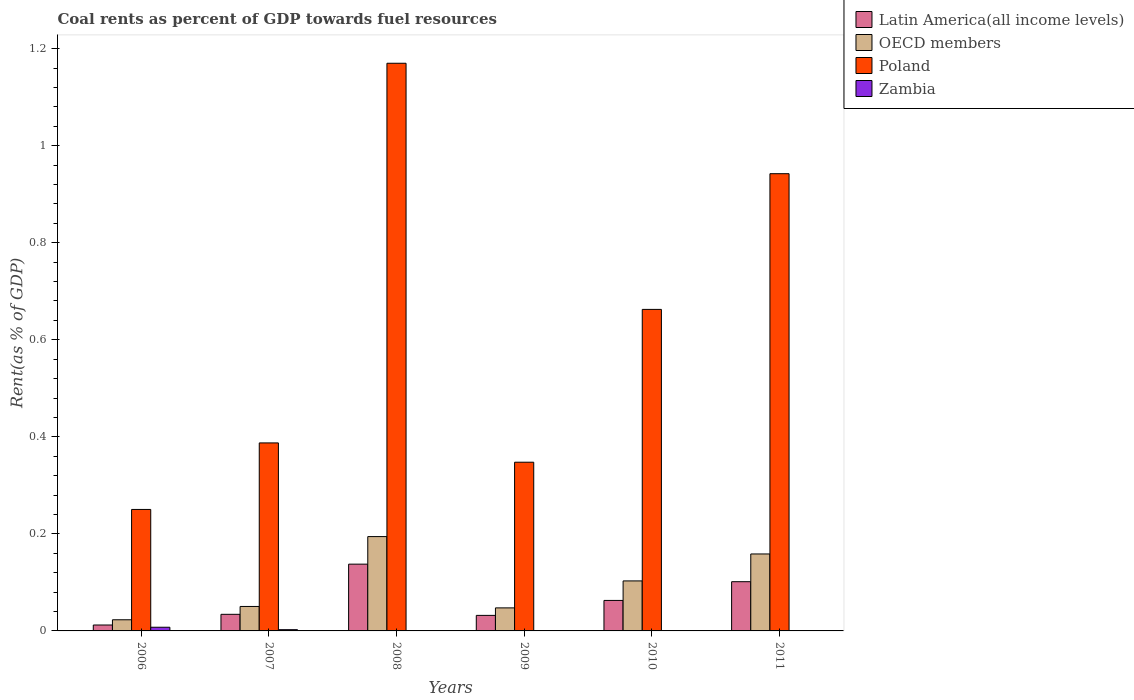How many groups of bars are there?
Ensure brevity in your answer.  6. Are the number of bars on each tick of the X-axis equal?
Provide a short and direct response. Yes. In how many cases, is the number of bars for a given year not equal to the number of legend labels?
Ensure brevity in your answer.  0. What is the coal rent in Zambia in 2011?
Your answer should be very brief. 0. Across all years, what is the maximum coal rent in Poland?
Your response must be concise. 1.17. Across all years, what is the minimum coal rent in Zambia?
Your response must be concise. 0. What is the total coal rent in Zambia in the graph?
Your response must be concise. 0.01. What is the difference between the coal rent in OECD members in 2010 and that in 2011?
Keep it short and to the point. -0.06. What is the difference between the coal rent in Zambia in 2011 and the coal rent in Poland in 2007?
Make the answer very short. -0.39. What is the average coal rent in Latin America(all income levels) per year?
Offer a terse response. 0.06. In the year 2011, what is the difference between the coal rent in Latin America(all income levels) and coal rent in Poland?
Give a very brief answer. -0.84. What is the ratio of the coal rent in Poland in 2009 to that in 2011?
Your response must be concise. 0.37. Is the coal rent in Latin America(all income levels) in 2007 less than that in 2011?
Offer a very short reply. Yes. What is the difference between the highest and the second highest coal rent in Latin America(all income levels)?
Ensure brevity in your answer.  0.04. What is the difference between the highest and the lowest coal rent in OECD members?
Make the answer very short. 0.17. Is the sum of the coal rent in Poland in 2007 and 2011 greater than the maximum coal rent in OECD members across all years?
Your answer should be very brief. Yes. What does the 4th bar from the left in 2010 represents?
Your response must be concise. Zambia. How many bars are there?
Offer a terse response. 24. Are all the bars in the graph horizontal?
Provide a succinct answer. No. How many years are there in the graph?
Offer a very short reply. 6. What is the difference between two consecutive major ticks on the Y-axis?
Your answer should be very brief. 0.2. Are the values on the major ticks of Y-axis written in scientific E-notation?
Your answer should be compact. No. How are the legend labels stacked?
Give a very brief answer. Vertical. What is the title of the graph?
Your response must be concise. Coal rents as percent of GDP towards fuel resources. Does "Micronesia" appear as one of the legend labels in the graph?
Make the answer very short. No. What is the label or title of the Y-axis?
Offer a very short reply. Rent(as % of GDP). What is the Rent(as % of GDP) in Latin America(all income levels) in 2006?
Your answer should be compact. 0.01. What is the Rent(as % of GDP) of OECD members in 2006?
Your answer should be very brief. 0.02. What is the Rent(as % of GDP) in Poland in 2006?
Keep it short and to the point. 0.25. What is the Rent(as % of GDP) of Zambia in 2006?
Your response must be concise. 0.01. What is the Rent(as % of GDP) of Latin America(all income levels) in 2007?
Offer a very short reply. 0.03. What is the Rent(as % of GDP) in OECD members in 2007?
Your answer should be very brief. 0.05. What is the Rent(as % of GDP) of Poland in 2007?
Provide a succinct answer. 0.39. What is the Rent(as % of GDP) of Zambia in 2007?
Provide a succinct answer. 0. What is the Rent(as % of GDP) in Latin America(all income levels) in 2008?
Your answer should be very brief. 0.14. What is the Rent(as % of GDP) of OECD members in 2008?
Offer a terse response. 0.19. What is the Rent(as % of GDP) of Poland in 2008?
Your response must be concise. 1.17. What is the Rent(as % of GDP) of Zambia in 2008?
Ensure brevity in your answer.  0. What is the Rent(as % of GDP) of Latin America(all income levels) in 2009?
Your answer should be compact. 0.03. What is the Rent(as % of GDP) of OECD members in 2009?
Your answer should be compact. 0.05. What is the Rent(as % of GDP) of Poland in 2009?
Offer a very short reply. 0.35. What is the Rent(as % of GDP) of Zambia in 2009?
Make the answer very short. 0. What is the Rent(as % of GDP) of Latin America(all income levels) in 2010?
Provide a succinct answer. 0.06. What is the Rent(as % of GDP) in OECD members in 2010?
Ensure brevity in your answer.  0.1. What is the Rent(as % of GDP) in Poland in 2010?
Offer a terse response. 0.66. What is the Rent(as % of GDP) of Zambia in 2010?
Provide a short and direct response. 0. What is the Rent(as % of GDP) in Latin America(all income levels) in 2011?
Your answer should be very brief. 0.1. What is the Rent(as % of GDP) of OECD members in 2011?
Your response must be concise. 0.16. What is the Rent(as % of GDP) of Poland in 2011?
Provide a succinct answer. 0.94. What is the Rent(as % of GDP) in Zambia in 2011?
Give a very brief answer. 0. Across all years, what is the maximum Rent(as % of GDP) of Latin America(all income levels)?
Your answer should be compact. 0.14. Across all years, what is the maximum Rent(as % of GDP) of OECD members?
Offer a terse response. 0.19. Across all years, what is the maximum Rent(as % of GDP) of Poland?
Your answer should be very brief. 1.17. Across all years, what is the maximum Rent(as % of GDP) of Zambia?
Make the answer very short. 0.01. Across all years, what is the minimum Rent(as % of GDP) of Latin America(all income levels)?
Offer a terse response. 0.01. Across all years, what is the minimum Rent(as % of GDP) in OECD members?
Provide a short and direct response. 0.02. Across all years, what is the minimum Rent(as % of GDP) of Poland?
Keep it short and to the point. 0.25. Across all years, what is the minimum Rent(as % of GDP) of Zambia?
Give a very brief answer. 0. What is the total Rent(as % of GDP) in Latin America(all income levels) in the graph?
Offer a terse response. 0.38. What is the total Rent(as % of GDP) in OECD members in the graph?
Your answer should be compact. 0.58. What is the total Rent(as % of GDP) in Poland in the graph?
Provide a short and direct response. 3.76. What is the total Rent(as % of GDP) of Zambia in the graph?
Your response must be concise. 0.01. What is the difference between the Rent(as % of GDP) in Latin America(all income levels) in 2006 and that in 2007?
Keep it short and to the point. -0.02. What is the difference between the Rent(as % of GDP) of OECD members in 2006 and that in 2007?
Provide a short and direct response. -0.03. What is the difference between the Rent(as % of GDP) of Poland in 2006 and that in 2007?
Provide a succinct answer. -0.14. What is the difference between the Rent(as % of GDP) of Zambia in 2006 and that in 2007?
Provide a succinct answer. 0.01. What is the difference between the Rent(as % of GDP) of Latin America(all income levels) in 2006 and that in 2008?
Give a very brief answer. -0.13. What is the difference between the Rent(as % of GDP) in OECD members in 2006 and that in 2008?
Ensure brevity in your answer.  -0.17. What is the difference between the Rent(as % of GDP) of Poland in 2006 and that in 2008?
Keep it short and to the point. -0.92. What is the difference between the Rent(as % of GDP) in Zambia in 2006 and that in 2008?
Provide a short and direct response. 0.01. What is the difference between the Rent(as % of GDP) in Latin America(all income levels) in 2006 and that in 2009?
Keep it short and to the point. -0.02. What is the difference between the Rent(as % of GDP) in OECD members in 2006 and that in 2009?
Your answer should be very brief. -0.02. What is the difference between the Rent(as % of GDP) of Poland in 2006 and that in 2009?
Your answer should be very brief. -0.1. What is the difference between the Rent(as % of GDP) in Zambia in 2006 and that in 2009?
Make the answer very short. 0.01. What is the difference between the Rent(as % of GDP) in Latin America(all income levels) in 2006 and that in 2010?
Provide a short and direct response. -0.05. What is the difference between the Rent(as % of GDP) in OECD members in 2006 and that in 2010?
Keep it short and to the point. -0.08. What is the difference between the Rent(as % of GDP) in Poland in 2006 and that in 2010?
Provide a short and direct response. -0.41. What is the difference between the Rent(as % of GDP) in Zambia in 2006 and that in 2010?
Provide a short and direct response. 0.01. What is the difference between the Rent(as % of GDP) in Latin America(all income levels) in 2006 and that in 2011?
Provide a succinct answer. -0.09. What is the difference between the Rent(as % of GDP) of OECD members in 2006 and that in 2011?
Give a very brief answer. -0.14. What is the difference between the Rent(as % of GDP) in Poland in 2006 and that in 2011?
Ensure brevity in your answer.  -0.69. What is the difference between the Rent(as % of GDP) in Zambia in 2006 and that in 2011?
Offer a very short reply. 0.01. What is the difference between the Rent(as % of GDP) in Latin America(all income levels) in 2007 and that in 2008?
Provide a short and direct response. -0.1. What is the difference between the Rent(as % of GDP) in OECD members in 2007 and that in 2008?
Your answer should be very brief. -0.14. What is the difference between the Rent(as % of GDP) of Poland in 2007 and that in 2008?
Your response must be concise. -0.78. What is the difference between the Rent(as % of GDP) of Zambia in 2007 and that in 2008?
Provide a short and direct response. 0. What is the difference between the Rent(as % of GDP) in Latin America(all income levels) in 2007 and that in 2009?
Your answer should be very brief. 0. What is the difference between the Rent(as % of GDP) in OECD members in 2007 and that in 2009?
Make the answer very short. 0. What is the difference between the Rent(as % of GDP) in Poland in 2007 and that in 2009?
Your response must be concise. 0.04. What is the difference between the Rent(as % of GDP) in Zambia in 2007 and that in 2009?
Your answer should be compact. 0. What is the difference between the Rent(as % of GDP) in Latin America(all income levels) in 2007 and that in 2010?
Keep it short and to the point. -0.03. What is the difference between the Rent(as % of GDP) of OECD members in 2007 and that in 2010?
Your answer should be compact. -0.05. What is the difference between the Rent(as % of GDP) in Poland in 2007 and that in 2010?
Keep it short and to the point. -0.28. What is the difference between the Rent(as % of GDP) in Zambia in 2007 and that in 2010?
Make the answer very short. 0. What is the difference between the Rent(as % of GDP) of Latin America(all income levels) in 2007 and that in 2011?
Offer a very short reply. -0.07. What is the difference between the Rent(as % of GDP) in OECD members in 2007 and that in 2011?
Give a very brief answer. -0.11. What is the difference between the Rent(as % of GDP) in Poland in 2007 and that in 2011?
Your response must be concise. -0.55. What is the difference between the Rent(as % of GDP) in Zambia in 2007 and that in 2011?
Give a very brief answer. 0. What is the difference between the Rent(as % of GDP) of Latin America(all income levels) in 2008 and that in 2009?
Ensure brevity in your answer.  0.11. What is the difference between the Rent(as % of GDP) of OECD members in 2008 and that in 2009?
Make the answer very short. 0.15. What is the difference between the Rent(as % of GDP) in Poland in 2008 and that in 2009?
Ensure brevity in your answer.  0.82. What is the difference between the Rent(as % of GDP) of Zambia in 2008 and that in 2009?
Keep it short and to the point. 0. What is the difference between the Rent(as % of GDP) in Latin America(all income levels) in 2008 and that in 2010?
Offer a terse response. 0.07. What is the difference between the Rent(as % of GDP) of OECD members in 2008 and that in 2010?
Your answer should be compact. 0.09. What is the difference between the Rent(as % of GDP) in Poland in 2008 and that in 2010?
Offer a terse response. 0.51. What is the difference between the Rent(as % of GDP) of Latin America(all income levels) in 2008 and that in 2011?
Ensure brevity in your answer.  0.04. What is the difference between the Rent(as % of GDP) of OECD members in 2008 and that in 2011?
Your answer should be compact. 0.04. What is the difference between the Rent(as % of GDP) of Poland in 2008 and that in 2011?
Provide a short and direct response. 0.23. What is the difference between the Rent(as % of GDP) in Zambia in 2008 and that in 2011?
Ensure brevity in your answer.  0. What is the difference between the Rent(as % of GDP) of Latin America(all income levels) in 2009 and that in 2010?
Your answer should be very brief. -0.03. What is the difference between the Rent(as % of GDP) in OECD members in 2009 and that in 2010?
Offer a terse response. -0.06. What is the difference between the Rent(as % of GDP) of Poland in 2009 and that in 2010?
Your answer should be compact. -0.32. What is the difference between the Rent(as % of GDP) in Zambia in 2009 and that in 2010?
Your answer should be compact. -0. What is the difference between the Rent(as % of GDP) of Latin America(all income levels) in 2009 and that in 2011?
Give a very brief answer. -0.07. What is the difference between the Rent(as % of GDP) of OECD members in 2009 and that in 2011?
Make the answer very short. -0.11. What is the difference between the Rent(as % of GDP) of Poland in 2009 and that in 2011?
Give a very brief answer. -0.59. What is the difference between the Rent(as % of GDP) in Zambia in 2009 and that in 2011?
Your answer should be compact. -0. What is the difference between the Rent(as % of GDP) of Latin America(all income levels) in 2010 and that in 2011?
Your answer should be very brief. -0.04. What is the difference between the Rent(as % of GDP) of OECD members in 2010 and that in 2011?
Your answer should be compact. -0.06. What is the difference between the Rent(as % of GDP) in Poland in 2010 and that in 2011?
Ensure brevity in your answer.  -0.28. What is the difference between the Rent(as % of GDP) in Zambia in 2010 and that in 2011?
Give a very brief answer. -0. What is the difference between the Rent(as % of GDP) in Latin America(all income levels) in 2006 and the Rent(as % of GDP) in OECD members in 2007?
Keep it short and to the point. -0.04. What is the difference between the Rent(as % of GDP) in Latin America(all income levels) in 2006 and the Rent(as % of GDP) in Poland in 2007?
Offer a terse response. -0.38. What is the difference between the Rent(as % of GDP) in Latin America(all income levels) in 2006 and the Rent(as % of GDP) in Zambia in 2007?
Keep it short and to the point. 0.01. What is the difference between the Rent(as % of GDP) of OECD members in 2006 and the Rent(as % of GDP) of Poland in 2007?
Offer a terse response. -0.36. What is the difference between the Rent(as % of GDP) in OECD members in 2006 and the Rent(as % of GDP) in Zambia in 2007?
Give a very brief answer. 0.02. What is the difference between the Rent(as % of GDP) in Poland in 2006 and the Rent(as % of GDP) in Zambia in 2007?
Make the answer very short. 0.25. What is the difference between the Rent(as % of GDP) of Latin America(all income levels) in 2006 and the Rent(as % of GDP) of OECD members in 2008?
Keep it short and to the point. -0.18. What is the difference between the Rent(as % of GDP) of Latin America(all income levels) in 2006 and the Rent(as % of GDP) of Poland in 2008?
Ensure brevity in your answer.  -1.16. What is the difference between the Rent(as % of GDP) of Latin America(all income levels) in 2006 and the Rent(as % of GDP) of Zambia in 2008?
Your answer should be compact. 0.01. What is the difference between the Rent(as % of GDP) in OECD members in 2006 and the Rent(as % of GDP) in Poland in 2008?
Offer a terse response. -1.15. What is the difference between the Rent(as % of GDP) in OECD members in 2006 and the Rent(as % of GDP) in Zambia in 2008?
Your answer should be very brief. 0.02. What is the difference between the Rent(as % of GDP) in Poland in 2006 and the Rent(as % of GDP) in Zambia in 2008?
Keep it short and to the point. 0.25. What is the difference between the Rent(as % of GDP) of Latin America(all income levels) in 2006 and the Rent(as % of GDP) of OECD members in 2009?
Offer a very short reply. -0.04. What is the difference between the Rent(as % of GDP) in Latin America(all income levels) in 2006 and the Rent(as % of GDP) in Poland in 2009?
Ensure brevity in your answer.  -0.34. What is the difference between the Rent(as % of GDP) of Latin America(all income levels) in 2006 and the Rent(as % of GDP) of Zambia in 2009?
Keep it short and to the point. 0.01. What is the difference between the Rent(as % of GDP) of OECD members in 2006 and the Rent(as % of GDP) of Poland in 2009?
Ensure brevity in your answer.  -0.32. What is the difference between the Rent(as % of GDP) in OECD members in 2006 and the Rent(as % of GDP) in Zambia in 2009?
Offer a terse response. 0.02. What is the difference between the Rent(as % of GDP) of Poland in 2006 and the Rent(as % of GDP) of Zambia in 2009?
Offer a very short reply. 0.25. What is the difference between the Rent(as % of GDP) of Latin America(all income levels) in 2006 and the Rent(as % of GDP) of OECD members in 2010?
Keep it short and to the point. -0.09. What is the difference between the Rent(as % of GDP) of Latin America(all income levels) in 2006 and the Rent(as % of GDP) of Poland in 2010?
Make the answer very short. -0.65. What is the difference between the Rent(as % of GDP) in Latin America(all income levels) in 2006 and the Rent(as % of GDP) in Zambia in 2010?
Your answer should be compact. 0.01. What is the difference between the Rent(as % of GDP) in OECD members in 2006 and the Rent(as % of GDP) in Poland in 2010?
Make the answer very short. -0.64. What is the difference between the Rent(as % of GDP) of OECD members in 2006 and the Rent(as % of GDP) of Zambia in 2010?
Your answer should be compact. 0.02. What is the difference between the Rent(as % of GDP) in Poland in 2006 and the Rent(as % of GDP) in Zambia in 2010?
Provide a succinct answer. 0.25. What is the difference between the Rent(as % of GDP) in Latin America(all income levels) in 2006 and the Rent(as % of GDP) in OECD members in 2011?
Keep it short and to the point. -0.15. What is the difference between the Rent(as % of GDP) of Latin America(all income levels) in 2006 and the Rent(as % of GDP) of Poland in 2011?
Provide a succinct answer. -0.93. What is the difference between the Rent(as % of GDP) of Latin America(all income levels) in 2006 and the Rent(as % of GDP) of Zambia in 2011?
Offer a terse response. 0.01. What is the difference between the Rent(as % of GDP) in OECD members in 2006 and the Rent(as % of GDP) in Poland in 2011?
Provide a succinct answer. -0.92. What is the difference between the Rent(as % of GDP) of OECD members in 2006 and the Rent(as % of GDP) of Zambia in 2011?
Give a very brief answer. 0.02. What is the difference between the Rent(as % of GDP) of Poland in 2006 and the Rent(as % of GDP) of Zambia in 2011?
Your response must be concise. 0.25. What is the difference between the Rent(as % of GDP) of Latin America(all income levels) in 2007 and the Rent(as % of GDP) of OECD members in 2008?
Keep it short and to the point. -0.16. What is the difference between the Rent(as % of GDP) in Latin America(all income levels) in 2007 and the Rent(as % of GDP) in Poland in 2008?
Your answer should be very brief. -1.14. What is the difference between the Rent(as % of GDP) in Latin America(all income levels) in 2007 and the Rent(as % of GDP) in Zambia in 2008?
Provide a short and direct response. 0.03. What is the difference between the Rent(as % of GDP) of OECD members in 2007 and the Rent(as % of GDP) of Poland in 2008?
Your answer should be very brief. -1.12. What is the difference between the Rent(as % of GDP) of OECD members in 2007 and the Rent(as % of GDP) of Zambia in 2008?
Offer a very short reply. 0.05. What is the difference between the Rent(as % of GDP) in Poland in 2007 and the Rent(as % of GDP) in Zambia in 2008?
Make the answer very short. 0.39. What is the difference between the Rent(as % of GDP) of Latin America(all income levels) in 2007 and the Rent(as % of GDP) of OECD members in 2009?
Give a very brief answer. -0.01. What is the difference between the Rent(as % of GDP) of Latin America(all income levels) in 2007 and the Rent(as % of GDP) of Poland in 2009?
Your response must be concise. -0.31. What is the difference between the Rent(as % of GDP) of Latin America(all income levels) in 2007 and the Rent(as % of GDP) of Zambia in 2009?
Provide a short and direct response. 0.03. What is the difference between the Rent(as % of GDP) in OECD members in 2007 and the Rent(as % of GDP) in Poland in 2009?
Keep it short and to the point. -0.3. What is the difference between the Rent(as % of GDP) of OECD members in 2007 and the Rent(as % of GDP) of Zambia in 2009?
Your answer should be very brief. 0.05. What is the difference between the Rent(as % of GDP) of Poland in 2007 and the Rent(as % of GDP) of Zambia in 2009?
Make the answer very short. 0.39. What is the difference between the Rent(as % of GDP) in Latin America(all income levels) in 2007 and the Rent(as % of GDP) in OECD members in 2010?
Your answer should be very brief. -0.07. What is the difference between the Rent(as % of GDP) of Latin America(all income levels) in 2007 and the Rent(as % of GDP) of Poland in 2010?
Your answer should be compact. -0.63. What is the difference between the Rent(as % of GDP) in Latin America(all income levels) in 2007 and the Rent(as % of GDP) in Zambia in 2010?
Provide a short and direct response. 0.03. What is the difference between the Rent(as % of GDP) in OECD members in 2007 and the Rent(as % of GDP) in Poland in 2010?
Make the answer very short. -0.61. What is the difference between the Rent(as % of GDP) of OECD members in 2007 and the Rent(as % of GDP) of Zambia in 2010?
Make the answer very short. 0.05. What is the difference between the Rent(as % of GDP) in Poland in 2007 and the Rent(as % of GDP) in Zambia in 2010?
Provide a short and direct response. 0.39. What is the difference between the Rent(as % of GDP) of Latin America(all income levels) in 2007 and the Rent(as % of GDP) of OECD members in 2011?
Your answer should be compact. -0.12. What is the difference between the Rent(as % of GDP) of Latin America(all income levels) in 2007 and the Rent(as % of GDP) of Poland in 2011?
Give a very brief answer. -0.91. What is the difference between the Rent(as % of GDP) in Latin America(all income levels) in 2007 and the Rent(as % of GDP) in Zambia in 2011?
Offer a very short reply. 0.03. What is the difference between the Rent(as % of GDP) of OECD members in 2007 and the Rent(as % of GDP) of Poland in 2011?
Your response must be concise. -0.89. What is the difference between the Rent(as % of GDP) in OECD members in 2007 and the Rent(as % of GDP) in Zambia in 2011?
Make the answer very short. 0.05. What is the difference between the Rent(as % of GDP) of Poland in 2007 and the Rent(as % of GDP) of Zambia in 2011?
Offer a very short reply. 0.39. What is the difference between the Rent(as % of GDP) in Latin America(all income levels) in 2008 and the Rent(as % of GDP) in OECD members in 2009?
Your answer should be compact. 0.09. What is the difference between the Rent(as % of GDP) in Latin America(all income levels) in 2008 and the Rent(as % of GDP) in Poland in 2009?
Your answer should be compact. -0.21. What is the difference between the Rent(as % of GDP) of Latin America(all income levels) in 2008 and the Rent(as % of GDP) of Zambia in 2009?
Give a very brief answer. 0.14. What is the difference between the Rent(as % of GDP) in OECD members in 2008 and the Rent(as % of GDP) in Poland in 2009?
Offer a very short reply. -0.15. What is the difference between the Rent(as % of GDP) in OECD members in 2008 and the Rent(as % of GDP) in Zambia in 2009?
Give a very brief answer. 0.19. What is the difference between the Rent(as % of GDP) of Poland in 2008 and the Rent(as % of GDP) of Zambia in 2009?
Make the answer very short. 1.17. What is the difference between the Rent(as % of GDP) of Latin America(all income levels) in 2008 and the Rent(as % of GDP) of OECD members in 2010?
Your response must be concise. 0.03. What is the difference between the Rent(as % of GDP) of Latin America(all income levels) in 2008 and the Rent(as % of GDP) of Poland in 2010?
Provide a succinct answer. -0.53. What is the difference between the Rent(as % of GDP) in Latin America(all income levels) in 2008 and the Rent(as % of GDP) in Zambia in 2010?
Provide a short and direct response. 0.14. What is the difference between the Rent(as % of GDP) of OECD members in 2008 and the Rent(as % of GDP) of Poland in 2010?
Offer a very short reply. -0.47. What is the difference between the Rent(as % of GDP) in OECD members in 2008 and the Rent(as % of GDP) in Zambia in 2010?
Your answer should be very brief. 0.19. What is the difference between the Rent(as % of GDP) of Poland in 2008 and the Rent(as % of GDP) of Zambia in 2010?
Provide a succinct answer. 1.17. What is the difference between the Rent(as % of GDP) of Latin America(all income levels) in 2008 and the Rent(as % of GDP) of OECD members in 2011?
Provide a short and direct response. -0.02. What is the difference between the Rent(as % of GDP) of Latin America(all income levels) in 2008 and the Rent(as % of GDP) of Poland in 2011?
Your answer should be very brief. -0.8. What is the difference between the Rent(as % of GDP) of Latin America(all income levels) in 2008 and the Rent(as % of GDP) of Zambia in 2011?
Your response must be concise. 0.14. What is the difference between the Rent(as % of GDP) of OECD members in 2008 and the Rent(as % of GDP) of Poland in 2011?
Keep it short and to the point. -0.75. What is the difference between the Rent(as % of GDP) of OECD members in 2008 and the Rent(as % of GDP) of Zambia in 2011?
Provide a succinct answer. 0.19. What is the difference between the Rent(as % of GDP) in Poland in 2008 and the Rent(as % of GDP) in Zambia in 2011?
Keep it short and to the point. 1.17. What is the difference between the Rent(as % of GDP) of Latin America(all income levels) in 2009 and the Rent(as % of GDP) of OECD members in 2010?
Provide a short and direct response. -0.07. What is the difference between the Rent(as % of GDP) in Latin America(all income levels) in 2009 and the Rent(as % of GDP) in Poland in 2010?
Offer a terse response. -0.63. What is the difference between the Rent(as % of GDP) in Latin America(all income levels) in 2009 and the Rent(as % of GDP) in Zambia in 2010?
Provide a short and direct response. 0.03. What is the difference between the Rent(as % of GDP) of OECD members in 2009 and the Rent(as % of GDP) of Poland in 2010?
Provide a succinct answer. -0.62. What is the difference between the Rent(as % of GDP) in OECD members in 2009 and the Rent(as % of GDP) in Zambia in 2010?
Your answer should be very brief. 0.05. What is the difference between the Rent(as % of GDP) in Poland in 2009 and the Rent(as % of GDP) in Zambia in 2010?
Ensure brevity in your answer.  0.35. What is the difference between the Rent(as % of GDP) of Latin America(all income levels) in 2009 and the Rent(as % of GDP) of OECD members in 2011?
Provide a succinct answer. -0.13. What is the difference between the Rent(as % of GDP) in Latin America(all income levels) in 2009 and the Rent(as % of GDP) in Poland in 2011?
Ensure brevity in your answer.  -0.91. What is the difference between the Rent(as % of GDP) of Latin America(all income levels) in 2009 and the Rent(as % of GDP) of Zambia in 2011?
Offer a very short reply. 0.03. What is the difference between the Rent(as % of GDP) of OECD members in 2009 and the Rent(as % of GDP) of Poland in 2011?
Provide a succinct answer. -0.89. What is the difference between the Rent(as % of GDP) of OECD members in 2009 and the Rent(as % of GDP) of Zambia in 2011?
Provide a short and direct response. 0.05. What is the difference between the Rent(as % of GDP) of Poland in 2009 and the Rent(as % of GDP) of Zambia in 2011?
Your response must be concise. 0.35. What is the difference between the Rent(as % of GDP) in Latin America(all income levels) in 2010 and the Rent(as % of GDP) in OECD members in 2011?
Offer a terse response. -0.1. What is the difference between the Rent(as % of GDP) of Latin America(all income levels) in 2010 and the Rent(as % of GDP) of Poland in 2011?
Your answer should be very brief. -0.88. What is the difference between the Rent(as % of GDP) of Latin America(all income levels) in 2010 and the Rent(as % of GDP) of Zambia in 2011?
Your answer should be compact. 0.06. What is the difference between the Rent(as % of GDP) in OECD members in 2010 and the Rent(as % of GDP) in Poland in 2011?
Your response must be concise. -0.84. What is the difference between the Rent(as % of GDP) of OECD members in 2010 and the Rent(as % of GDP) of Zambia in 2011?
Provide a short and direct response. 0.1. What is the difference between the Rent(as % of GDP) in Poland in 2010 and the Rent(as % of GDP) in Zambia in 2011?
Ensure brevity in your answer.  0.66. What is the average Rent(as % of GDP) in Latin America(all income levels) per year?
Provide a succinct answer. 0.06. What is the average Rent(as % of GDP) in OECD members per year?
Make the answer very short. 0.1. What is the average Rent(as % of GDP) of Poland per year?
Provide a short and direct response. 0.63. What is the average Rent(as % of GDP) of Zambia per year?
Make the answer very short. 0. In the year 2006, what is the difference between the Rent(as % of GDP) of Latin America(all income levels) and Rent(as % of GDP) of OECD members?
Your response must be concise. -0.01. In the year 2006, what is the difference between the Rent(as % of GDP) of Latin America(all income levels) and Rent(as % of GDP) of Poland?
Provide a succinct answer. -0.24. In the year 2006, what is the difference between the Rent(as % of GDP) of Latin America(all income levels) and Rent(as % of GDP) of Zambia?
Your answer should be compact. 0. In the year 2006, what is the difference between the Rent(as % of GDP) in OECD members and Rent(as % of GDP) in Poland?
Give a very brief answer. -0.23. In the year 2006, what is the difference between the Rent(as % of GDP) of OECD members and Rent(as % of GDP) of Zambia?
Ensure brevity in your answer.  0.02. In the year 2006, what is the difference between the Rent(as % of GDP) of Poland and Rent(as % of GDP) of Zambia?
Give a very brief answer. 0.24. In the year 2007, what is the difference between the Rent(as % of GDP) of Latin America(all income levels) and Rent(as % of GDP) of OECD members?
Offer a terse response. -0.02. In the year 2007, what is the difference between the Rent(as % of GDP) in Latin America(all income levels) and Rent(as % of GDP) in Poland?
Ensure brevity in your answer.  -0.35. In the year 2007, what is the difference between the Rent(as % of GDP) in Latin America(all income levels) and Rent(as % of GDP) in Zambia?
Make the answer very short. 0.03. In the year 2007, what is the difference between the Rent(as % of GDP) of OECD members and Rent(as % of GDP) of Poland?
Your response must be concise. -0.34. In the year 2007, what is the difference between the Rent(as % of GDP) of OECD members and Rent(as % of GDP) of Zambia?
Make the answer very short. 0.05. In the year 2007, what is the difference between the Rent(as % of GDP) of Poland and Rent(as % of GDP) of Zambia?
Offer a terse response. 0.38. In the year 2008, what is the difference between the Rent(as % of GDP) in Latin America(all income levels) and Rent(as % of GDP) in OECD members?
Offer a terse response. -0.06. In the year 2008, what is the difference between the Rent(as % of GDP) in Latin America(all income levels) and Rent(as % of GDP) in Poland?
Offer a very short reply. -1.03. In the year 2008, what is the difference between the Rent(as % of GDP) of Latin America(all income levels) and Rent(as % of GDP) of Zambia?
Provide a short and direct response. 0.14. In the year 2008, what is the difference between the Rent(as % of GDP) of OECD members and Rent(as % of GDP) of Poland?
Keep it short and to the point. -0.98. In the year 2008, what is the difference between the Rent(as % of GDP) in OECD members and Rent(as % of GDP) in Zambia?
Offer a terse response. 0.19. In the year 2008, what is the difference between the Rent(as % of GDP) in Poland and Rent(as % of GDP) in Zambia?
Provide a succinct answer. 1.17. In the year 2009, what is the difference between the Rent(as % of GDP) of Latin America(all income levels) and Rent(as % of GDP) of OECD members?
Provide a succinct answer. -0.02. In the year 2009, what is the difference between the Rent(as % of GDP) in Latin America(all income levels) and Rent(as % of GDP) in Poland?
Ensure brevity in your answer.  -0.32. In the year 2009, what is the difference between the Rent(as % of GDP) in Latin America(all income levels) and Rent(as % of GDP) in Zambia?
Ensure brevity in your answer.  0.03. In the year 2009, what is the difference between the Rent(as % of GDP) in OECD members and Rent(as % of GDP) in Poland?
Give a very brief answer. -0.3. In the year 2009, what is the difference between the Rent(as % of GDP) of OECD members and Rent(as % of GDP) of Zambia?
Your answer should be compact. 0.05. In the year 2009, what is the difference between the Rent(as % of GDP) of Poland and Rent(as % of GDP) of Zambia?
Give a very brief answer. 0.35. In the year 2010, what is the difference between the Rent(as % of GDP) of Latin America(all income levels) and Rent(as % of GDP) of OECD members?
Give a very brief answer. -0.04. In the year 2010, what is the difference between the Rent(as % of GDP) of Latin America(all income levels) and Rent(as % of GDP) of Poland?
Offer a very short reply. -0.6. In the year 2010, what is the difference between the Rent(as % of GDP) of Latin America(all income levels) and Rent(as % of GDP) of Zambia?
Your answer should be compact. 0.06. In the year 2010, what is the difference between the Rent(as % of GDP) of OECD members and Rent(as % of GDP) of Poland?
Ensure brevity in your answer.  -0.56. In the year 2010, what is the difference between the Rent(as % of GDP) in OECD members and Rent(as % of GDP) in Zambia?
Give a very brief answer. 0.1. In the year 2010, what is the difference between the Rent(as % of GDP) in Poland and Rent(as % of GDP) in Zambia?
Ensure brevity in your answer.  0.66. In the year 2011, what is the difference between the Rent(as % of GDP) of Latin America(all income levels) and Rent(as % of GDP) of OECD members?
Your response must be concise. -0.06. In the year 2011, what is the difference between the Rent(as % of GDP) in Latin America(all income levels) and Rent(as % of GDP) in Poland?
Provide a succinct answer. -0.84. In the year 2011, what is the difference between the Rent(as % of GDP) in Latin America(all income levels) and Rent(as % of GDP) in Zambia?
Your answer should be very brief. 0.1. In the year 2011, what is the difference between the Rent(as % of GDP) in OECD members and Rent(as % of GDP) in Poland?
Give a very brief answer. -0.78. In the year 2011, what is the difference between the Rent(as % of GDP) of OECD members and Rent(as % of GDP) of Zambia?
Provide a short and direct response. 0.16. In the year 2011, what is the difference between the Rent(as % of GDP) in Poland and Rent(as % of GDP) in Zambia?
Offer a very short reply. 0.94. What is the ratio of the Rent(as % of GDP) of Latin America(all income levels) in 2006 to that in 2007?
Provide a succinct answer. 0.36. What is the ratio of the Rent(as % of GDP) in OECD members in 2006 to that in 2007?
Offer a terse response. 0.46. What is the ratio of the Rent(as % of GDP) of Poland in 2006 to that in 2007?
Ensure brevity in your answer.  0.65. What is the ratio of the Rent(as % of GDP) in Zambia in 2006 to that in 2007?
Keep it short and to the point. 2.96. What is the ratio of the Rent(as % of GDP) of Latin America(all income levels) in 2006 to that in 2008?
Give a very brief answer. 0.09. What is the ratio of the Rent(as % of GDP) in OECD members in 2006 to that in 2008?
Your response must be concise. 0.12. What is the ratio of the Rent(as % of GDP) in Poland in 2006 to that in 2008?
Provide a succinct answer. 0.21. What is the ratio of the Rent(as % of GDP) in Zambia in 2006 to that in 2008?
Offer a very short reply. 17.16. What is the ratio of the Rent(as % of GDP) in Latin America(all income levels) in 2006 to that in 2009?
Make the answer very short. 0.38. What is the ratio of the Rent(as % of GDP) in OECD members in 2006 to that in 2009?
Offer a very short reply. 0.48. What is the ratio of the Rent(as % of GDP) in Poland in 2006 to that in 2009?
Offer a very short reply. 0.72. What is the ratio of the Rent(as % of GDP) of Zambia in 2006 to that in 2009?
Ensure brevity in your answer.  43.63. What is the ratio of the Rent(as % of GDP) of Latin America(all income levels) in 2006 to that in 2010?
Your answer should be compact. 0.19. What is the ratio of the Rent(as % of GDP) of OECD members in 2006 to that in 2010?
Provide a succinct answer. 0.22. What is the ratio of the Rent(as % of GDP) of Poland in 2006 to that in 2010?
Your answer should be very brief. 0.38. What is the ratio of the Rent(as % of GDP) in Zambia in 2006 to that in 2010?
Ensure brevity in your answer.  31.8. What is the ratio of the Rent(as % of GDP) of Latin America(all income levels) in 2006 to that in 2011?
Your answer should be very brief. 0.12. What is the ratio of the Rent(as % of GDP) of OECD members in 2006 to that in 2011?
Offer a very short reply. 0.14. What is the ratio of the Rent(as % of GDP) of Poland in 2006 to that in 2011?
Ensure brevity in your answer.  0.27. What is the ratio of the Rent(as % of GDP) in Zambia in 2006 to that in 2011?
Your answer should be very brief. 25.55. What is the ratio of the Rent(as % of GDP) in Latin America(all income levels) in 2007 to that in 2008?
Ensure brevity in your answer.  0.25. What is the ratio of the Rent(as % of GDP) in OECD members in 2007 to that in 2008?
Keep it short and to the point. 0.26. What is the ratio of the Rent(as % of GDP) of Poland in 2007 to that in 2008?
Make the answer very short. 0.33. What is the ratio of the Rent(as % of GDP) in Zambia in 2007 to that in 2008?
Provide a short and direct response. 5.81. What is the ratio of the Rent(as % of GDP) in Latin America(all income levels) in 2007 to that in 2009?
Your answer should be compact. 1.07. What is the ratio of the Rent(as % of GDP) of OECD members in 2007 to that in 2009?
Provide a short and direct response. 1.06. What is the ratio of the Rent(as % of GDP) in Poland in 2007 to that in 2009?
Offer a very short reply. 1.11. What is the ratio of the Rent(as % of GDP) of Zambia in 2007 to that in 2009?
Provide a succinct answer. 14.76. What is the ratio of the Rent(as % of GDP) of Latin America(all income levels) in 2007 to that in 2010?
Your response must be concise. 0.54. What is the ratio of the Rent(as % of GDP) in OECD members in 2007 to that in 2010?
Provide a succinct answer. 0.49. What is the ratio of the Rent(as % of GDP) of Poland in 2007 to that in 2010?
Offer a very short reply. 0.58. What is the ratio of the Rent(as % of GDP) in Zambia in 2007 to that in 2010?
Your response must be concise. 10.76. What is the ratio of the Rent(as % of GDP) in Latin America(all income levels) in 2007 to that in 2011?
Make the answer very short. 0.34. What is the ratio of the Rent(as % of GDP) of OECD members in 2007 to that in 2011?
Your response must be concise. 0.32. What is the ratio of the Rent(as % of GDP) of Poland in 2007 to that in 2011?
Offer a terse response. 0.41. What is the ratio of the Rent(as % of GDP) of Zambia in 2007 to that in 2011?
Keep it short and to the point. 8.65. What is the ratio of the Rent(as % of GDP) in Latin America(all income levels) in 2008 to that in 2009?
Offer a very short reply. 4.3. What is the ratio of the Rent(as % of GDP) in OECD members in 2008 to that in 2009?
Provide a short and direct response. 4.09. What is the ratio of the Rent(as % of GDP) of Poland in 2008 to that in 2009?
Keep it short and to the point. 3.36. What is the ratio of the Rent(as % of GDP) in Zambia in 2008 to that in 2009?
Give a very brief answer. 2.54. What is the ratio of the Rent(as % of GDP) in Latin America(all income levels) in 2008 to that in 2010?
Offer a terse response. 2.19. What is the ratio of the Rent(as % of GDP) of OECD members in 2008 to that in 2010?
Give a very brief answer. 1.89. What is the ratio of the Rent(as % of GDP) of Poland in 2008 to that in 2010?
Your answer should be compact. 1.77. What is the ratio of the Rent(as % of GDP) in Zambia in 2008 to that in 2010?
Give a very brief answer. 1.85. What is the ratio of the Rent(as % of GDP) of Latin America(all income levels) in 2008 to that in 2011?
Ensure brevity in your answer.  1.36. What is the ratio of the Rent(as % of GDP) of OECD members in 2008 to that in 2011?
Your response must be concise. 1.23. What is the ratio of the Rent(as % of GDP) of Poland in 2008 to that in 2011?
Your response must be concise. 1.24. What is the ratio of the Rent(as % of GDP) in Zambia in 2008 to that in 2011?
Offer a terse response. 1.49. What is the ratio of the Rent(as % of GDP) of Latin America(all income levels) in 2009 to that in 2010?
Your answer should be compact. 0.51. What is the ratio of the Rent(as % of GDP) of OECD members in 2009 to that in 2010?
Give a very brief answer. 0.46. What is the ratio of the Rent(as % of GDP) of Poland in 2009 to that in 2010?
Your answer should be very brief. 0.52. What is the ratio of the Rent(as % of GDP) of Zambia in 2009 to that in 2010?
Offer a terse response. 0.73. What is the ratio of the Rent(as % of GDP) in Latin America(all income levels) in 2009 to that in 2011?
Keep it short and to the point. 0.32. What is the ratio of the Rent(as % of GDP) in OECD members in 2009 to that in 2011?
Your response must be concise. 0.3. What is the ratio of the Rent(as % of GDP) in Poland in 2009 to that in 2011?
Ensure brevity in your answer.  0.37. What is the ratio of the Rent(as % of GDP) of Zambia in 2009 to that in 2011?
Offer a very short reply. 0.59. What is the ratio of the Rent(as % of GDP) of Latin America(all income levels) in 2010 to that in 2011?
Give a very brief answer. 0.62. What is the ratio of the Rent(as % of GDP) of OECD members in 2010 to that in 2011?
Give a very brief answer. 0.65. What is the ratio of the Rent(as % of GDP) of Poland in 2010 to that in 2011?
Offer a terse response. 0.7. What is the ratio of the Rent(as % of GDP) in Zambia in 2010 to that in 2011?
Keep it short and to the point. 0.8. What is the difference between the highest and the second highest Rent(as % of GDP) of Latin America(all income levels)?
Ensure brevity in your answer.  0.04. What is the difference between the highest and the second highest Rent(as % of GDP) in OECD members?
Your response must be concise. 0.04. What is the difference between the highest and the second highest Rent(as % of GDP) in Poland?
Keep it short and to the point. 0.23. What is the difference between the highest and the second highest Rent(as % of GDP) of Zambia?
Keep it short and to the point. 0.01. What is the difference between the highest and the lowest Rent(as % of GDP) in Latin America(all income levels)?
Offer a terse response. 0.13. What is the difference between the highest and the lowest Rent(as % of GDP) of OECD members?
Provide a succinct answer. 0.17. What is the difference between the highest and the lowest Rent(as % of GDP) of Poland?
Provide a short and direct response. 0.92. What is the difference between the highest and the lowest Rent(as % of GDP) in Zambia?
Provide a short and direct response. 0.01. 